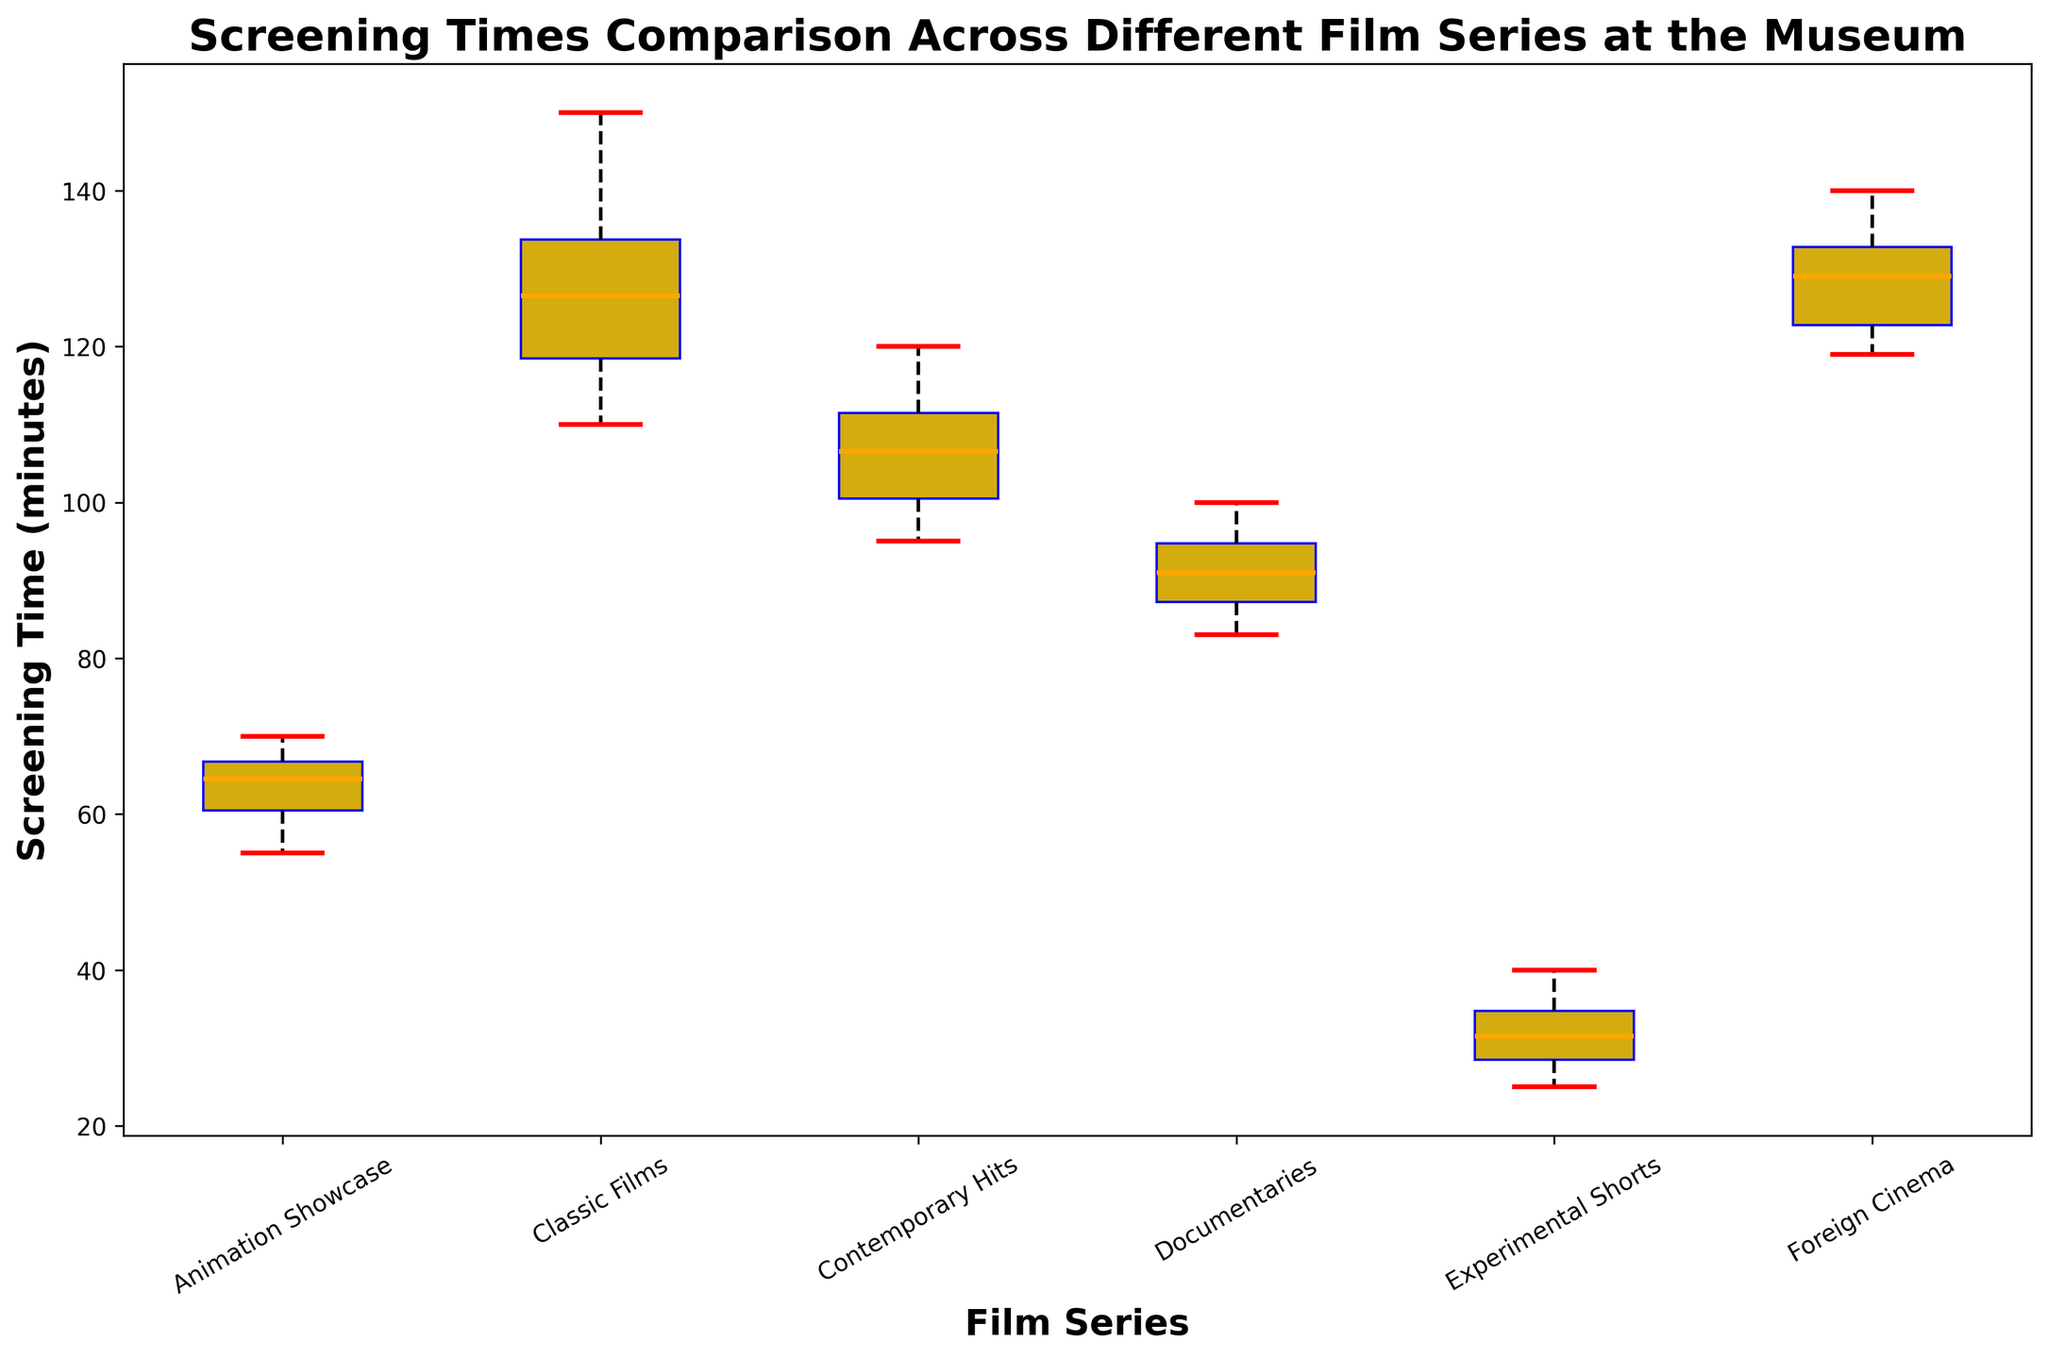What is the median screening time for the "Classic Films" series? To find the median, locate the middle value of the sorted screening times for "Classic Films". The sorted times are [110, 115, 118, 120, 125, 128, 130, 135, 140, 150]. The median is the average of the 5th and 6th values: (125 + 128) / 2 = 126.5.
Answer: 126.5 Which film series has the longest screening time? Examine the highest points of the box plots across all series. The "Classic Films" series has the longest screening time of 150 minutes.
Answer: Classic Films Between "Documentaries" and "Animation Showcase," which has the lower median screening time? Identify the median line within each box plot. The median for "Documentaries" is approximately 92, while for "Animation Showcase," it is 63. Thus, "Documentaries" has the lower median screening time.
Answer: Documentaries How much longer is the range (maximum minus minimum) of screening times for "Classic Films" compared to "Experimental Shorts"? Calculate the range for each series. For "Classic Films": 150 - 110 = 40. For "Experimental Shorts": 40 - 25 = 15. The difference in ranges is 40 - 15 = 25 minutes.
Answer: 25 Which film series has the most consistent (least variable) screening time? Look for the shortest interquartile range (IQR). "Contemporary Hits" and "Documentaries" have closely packed boxes, but "Experimental Shorts" has the smallest box, indicating it has the least variability.
Answer: Experimental Shorts What color represents the median line in the box plots? Observe the color of the line that splits each box plot in half. The median line is colored orange.
Answer: Orange Which film series has a lower quartile higher than the maximum of another series? Compare the lower quartile (bottom of each box) with the maximum of all others. The lower quartile of "Foreign Cinema" is higher than the maximum of "Documentaries" and "Experimental Shorts".
Answer: Foreign Cinema What is the position of the median line in the box plot for "Contemporary Hits" compared to "Animation Showcase"? Visually inspect the position of the median lines in each box plot. The median for "Contemporary Hits" (around 102-105) is significantly higher than the median for "Animation Showcase" (around 63).
Answer: Higher How does the screening time distribution of "Documentaries" compare with that of "Foreign Cinema"? "Documentaries" have a lower range and median, with screening times tightly clustered around the lower end (75 to 100), whereas "Foreign Cinema" has a wider range and higher median (119 to 140).
Answer: "Documentaries" are shorter and more tightly clustered compared to "Foreign Cinema" Which film series’ lower whisker is the longest? Look for the whisker extending furthest down. The "Classic Films" series has the longest lower whisker, reaching down to 110 minutes.
Answer: Classic Films 